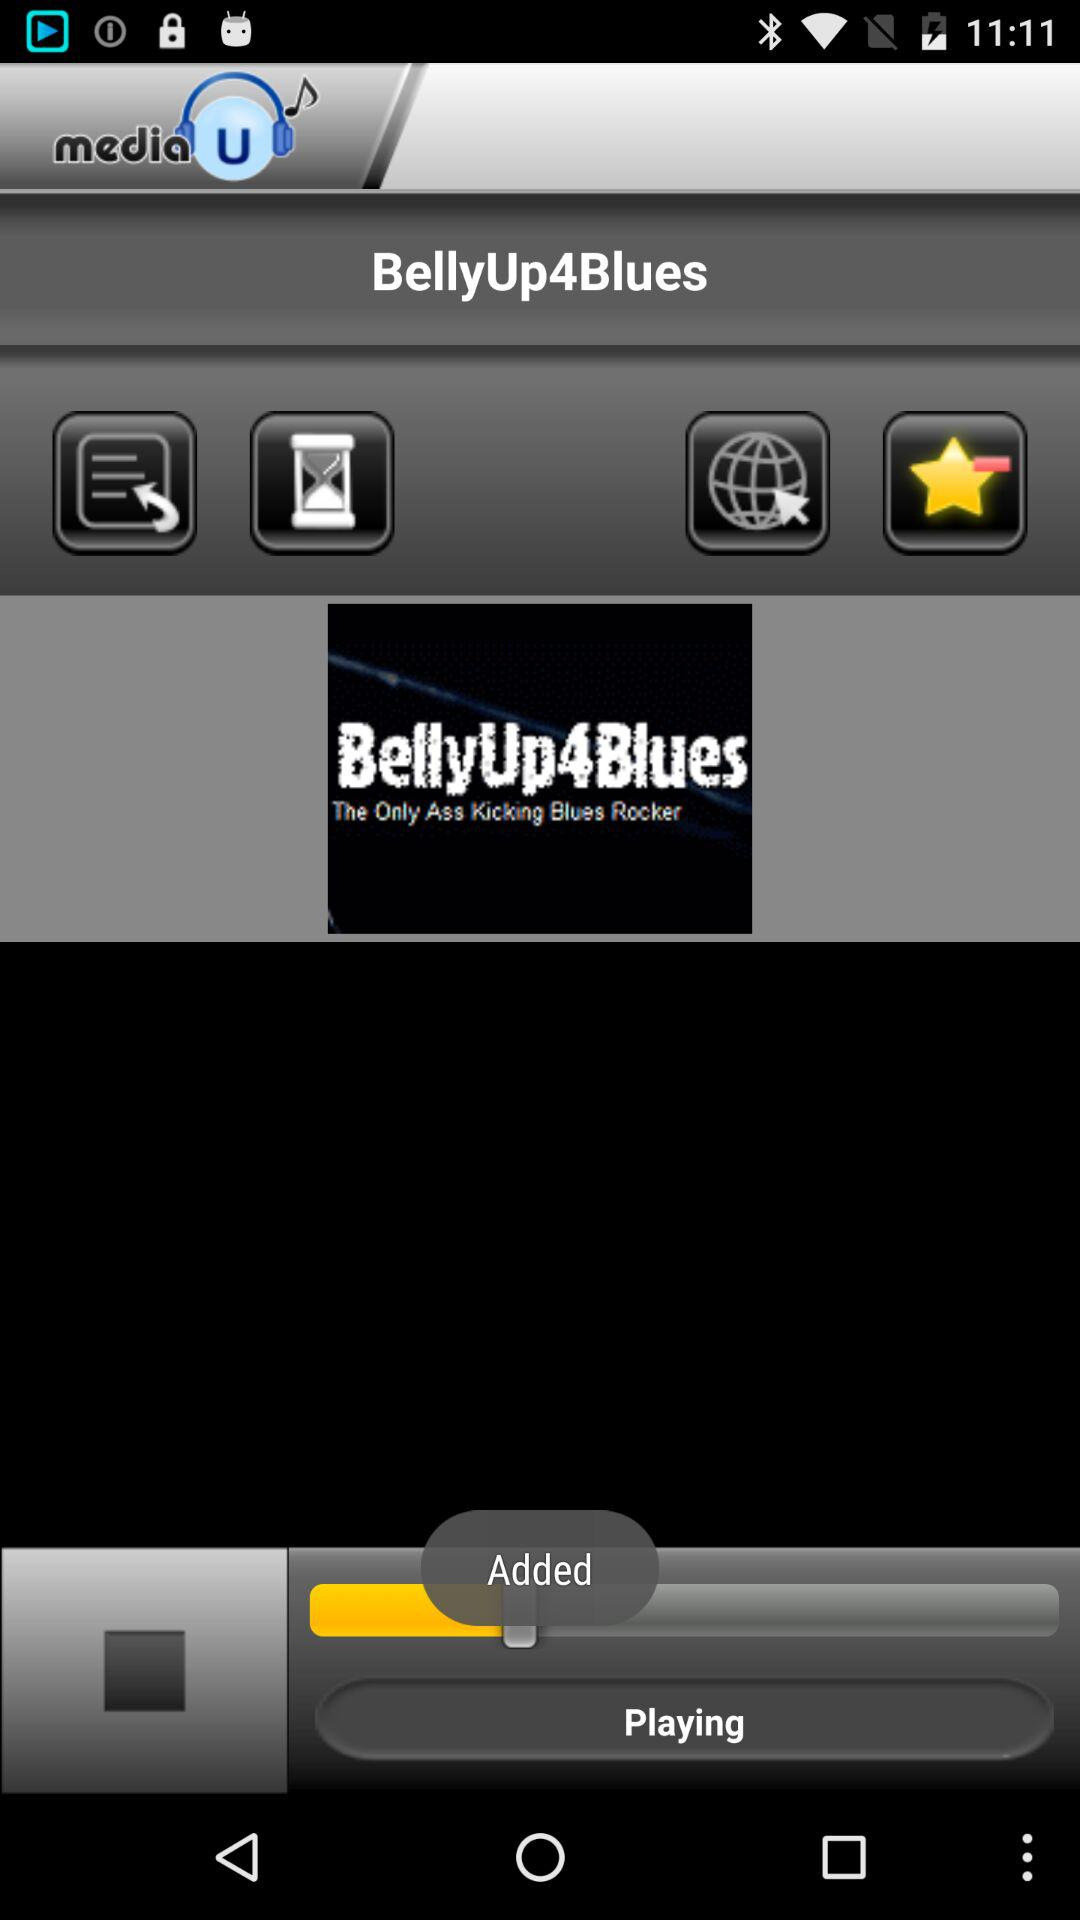What is the application name? The application name is "media U". 